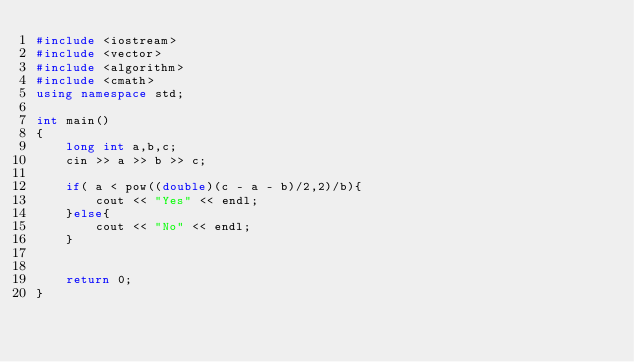<code> <loc_0><loc_0><loc_500><loc_500><_C++_>#include <iostream>
#include <vector>
#include <algorithm>
#include <cmath>
using namespace std;

int main()
{
    long int a,b,c;
    cin >> a >> b >> c;

    if( a < pow((double)(c - a - b)/2,2)/b){
        cout << "Yes" << endl;
    }else{
        cout << "No" << endl;
    }


    return 0;
}</code> 